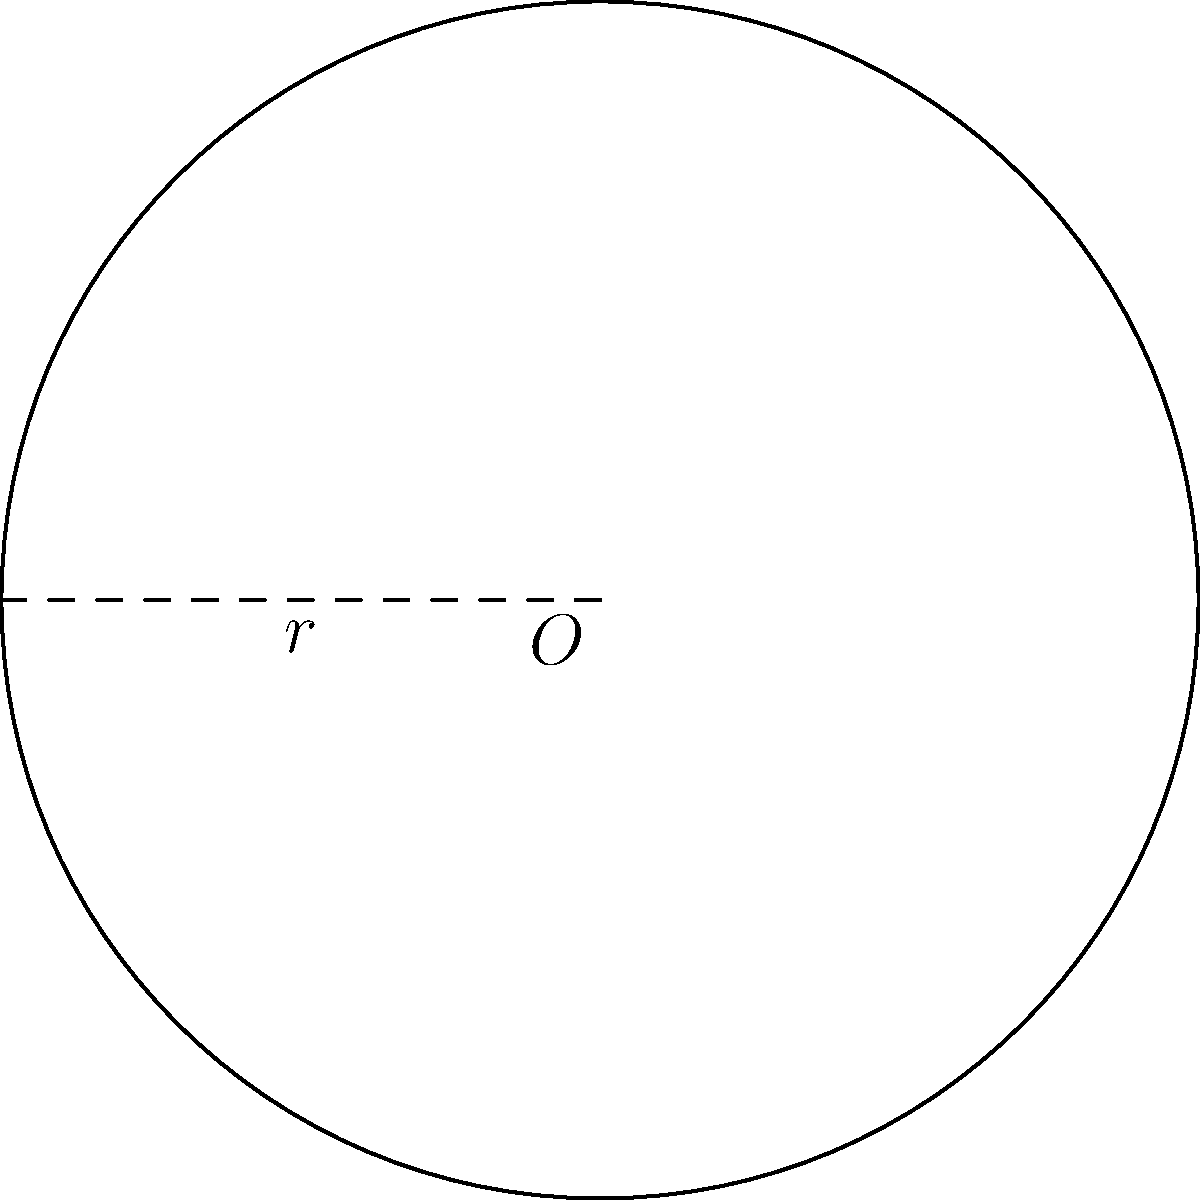During a Tour de France stage, a commentator mentions that a cyclist's wheel has a radius of 34.5 cm. What is the perimeter of this wheel? (Use $\pi \approx 3.14159$ for your calculations and round your answer to the nearest centimeter.) To find the perimeter of a circular wheel, we need to calculate its circumference. The formula for the circumference of a circle is:

$$C = 2\pi r$$

Where:
$C$ is the circumference (perimeter)
$\pi$ is pi (approximately 3.14159)
$r$ is the radius

Given:
$r = 34.5$ cm
$\pi \approx 3.14159$

Let's substitute these values into the formula:

$$\begin{align}
C &= 2\pi r \\
&= 2 \times 3.14159 \times 34.5 \\
&= 216.76971 \text{ cm}
\end{align}$$

Rounding to the nearest centimeter:

$$C \approx 217 \text{ cm}$$
Answer: 217 cm 